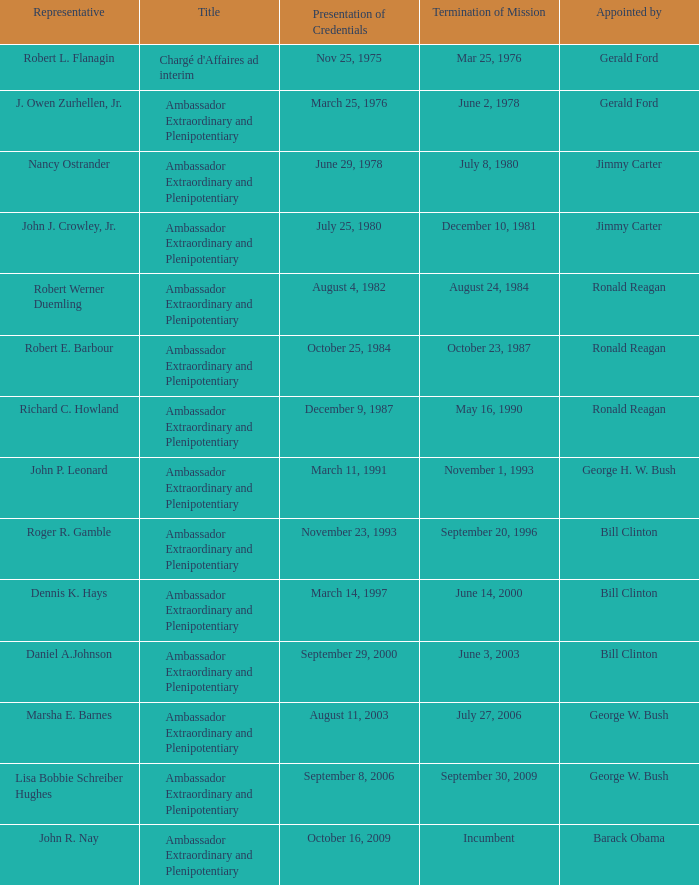Parse the table in full. {'header': ['Representative', 'Title', 'Presentation of Credentials', 'Termination of Mission', 'Appointed by'], 'rows': [['Robert L. Flanagin', "Chargé d'Affaires ad interim", 'Nov 25, 1975', 'Mar 25, 1976', 'Gerald Ford'], ['J. Owen Zurhellen, Jr.', 'Ambassador Extraordinary and Plenipotentiary', 'March 25, 1976', 'June 2, 1978', 'Gerald Ford'], ['Nancy Ostrander', 'Ambassador Extraordinary and Plenipotentiary', 'June 29, 1978', 'July 8, 1980', 'Jimmy Carter'], ['John J. Crowley, Jr.', 'Ambassador Extraordinary and Plenipotentiary', 'July 25, 1980', 'December 10, 1981', 'Jimmy Carter'], ['Robert Werner Duemling', 'Ambassador Extraordinary and Plenipotentiary', 'August 4, 1982', 'August 24, 1984', 'Ronald Reagan'], ['Robert E. Barbour', 'Ambassador Extraordinary and Plenipotentiary', 'October 25, 1984', 'October 23, 1987', 'Ronald Reagan'], ['Richard C. Howland', 'Ambassador Extraordinary and Plenipotentiary', 'December 9, 1987', 'May 16, 1990', 'Ronald Reagan'], ['John P. Leonard', 'Ambassador Extraordinary and Plenipotentiary', 'March 11, 1991', 'November 1, 1993', 'George H. W. Bush'], ['Roger R. Gamble', 'Ambassador Extraordinary and Plenipotentiary', 'November 23, 1993', 'September 20, 1996', 'Bill Clinton'], ['Dennis K. Hays', 'Ambassador Extraordinary and Plenipotentiary', 'March 14, 1997', 'June 14, 2000', 'Bill Clinton'], ['Daniel A.Johnson', 'Ambassador Extraordinary and Plenipotentiary', 'September 29, 2000', 'June 3, 2003', 'Bill Clinton'], ['Marsha E. Barnes', 'Ambassador Extraordinary and Plenipotentiary', 'August 11, 2003', 'July 27, 2006', 'George W. Bush'], ['Lisa Bobbie Schreiber Hughes', 'Ambassador Extraordinary and Plenipotentiary', 'September 8, 2006', 'September 30, 2009', 'George W. Bush'], ['John R. Nay', 'Ambassador Extraordinary and Plenipotentiary', 'October 16, 2009', 'Incumbent', 'Barack Obama']]} Which delegate served as the ambassador extraordinary and plenipotentiary with a mission end date of september 20, 1996? Roger R. Gamble. 